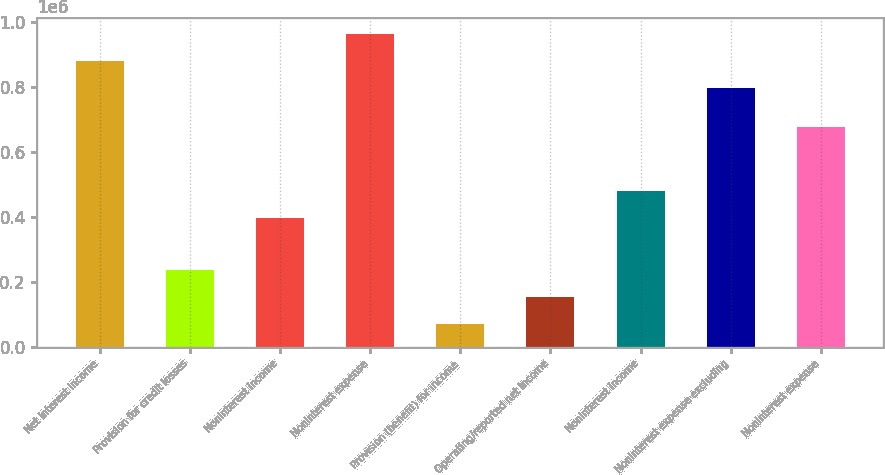Convert chart to OTSL. <chart><loc_0><loc_0><loc_500><loc_500><bar_chart><fcel>Net interest income<fcel>Provision for credit losses<fcel>NonInterest income<fcel>NonInterest expense<fcel>Provision (benefit) for income<fcel>Operating/reported net income<fcel>Noninterest income<fcel>Noninterest expense excluding<fcel>Noninterest expense<nl><fcel>879877<fcel>236884<fcel>394705<fcel>963040<fcel>70558<fcel>153721<fcel>477868<fcel>796714<fcel>675720<nl></chart> 